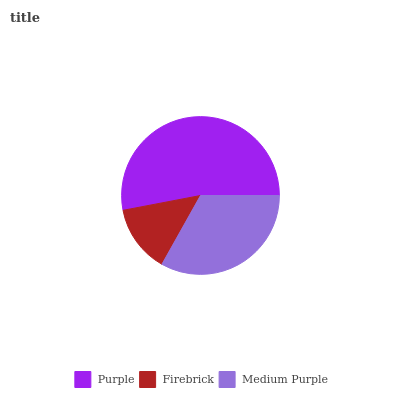Is Firebrick the minimum?
Answer yes or no. Yes. Is Purple the maximum?
Answer yes or no. Yes. Is Medium Purple the minimum?
Answer yes or no. No. Is Medium Purple the maximum?
Answer yes or no. No. Is Medium Purple greater than Firebrick?
Answer yes or no. Yes. Is Firebrick less than Medium Purple?
Answer yes or no. Yes. Is Firebrick greater than Medium Purple?
Answer yes or no. No. Is Medium Purple less than Firebrick?
Answer yes or no. No. Is Medium Purple the high median?
Answer yes or no. Yes. Is Medium Purple the low median?
Answer yes or no. Yes. Is Purple the high median?
Answer yes or no. No. Is Purple the low median?
Answer yes or no. No. 